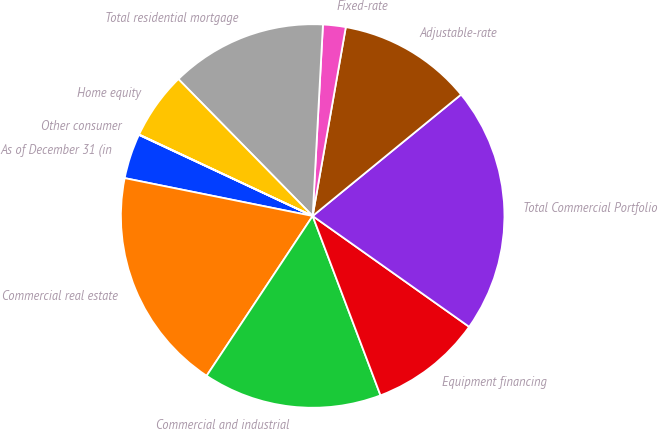<chart> <loc_0><loc_0><loc_500><loc_500><pie_chart><fcel>As of December 31 (in<fcel>Commercial real estate<fcel>Commercial and industrial<fcel>Equipment financing<fcel>Total Commercial Portfolio<fcel>Adjustable-rate<fcel>Fixed-rate<fcel>Total residential mortgage<fcel>Home equity<fcel>Other consumer<nl><fcel>3.79%<fcel>18.84%<fcel>15.08%<fcel>9.44%<fcel>20.72%<fcel>11.32%<fcel>1.91%<fcel>13.2%<fcel>5.67%<fcel>0.03%<nl></chart> 